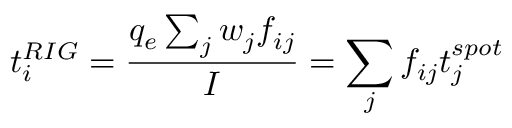<formula> <loc_0><loc_0><loc_500><loc_500>t _ { i } ^ { R I G } = \frac { q _ { e } \sum _ { j } w _ { j } f _ { i j } } { I } = \sum _ { j } f _ { i j } t _ { j } ^ { s p o t }</formula> 